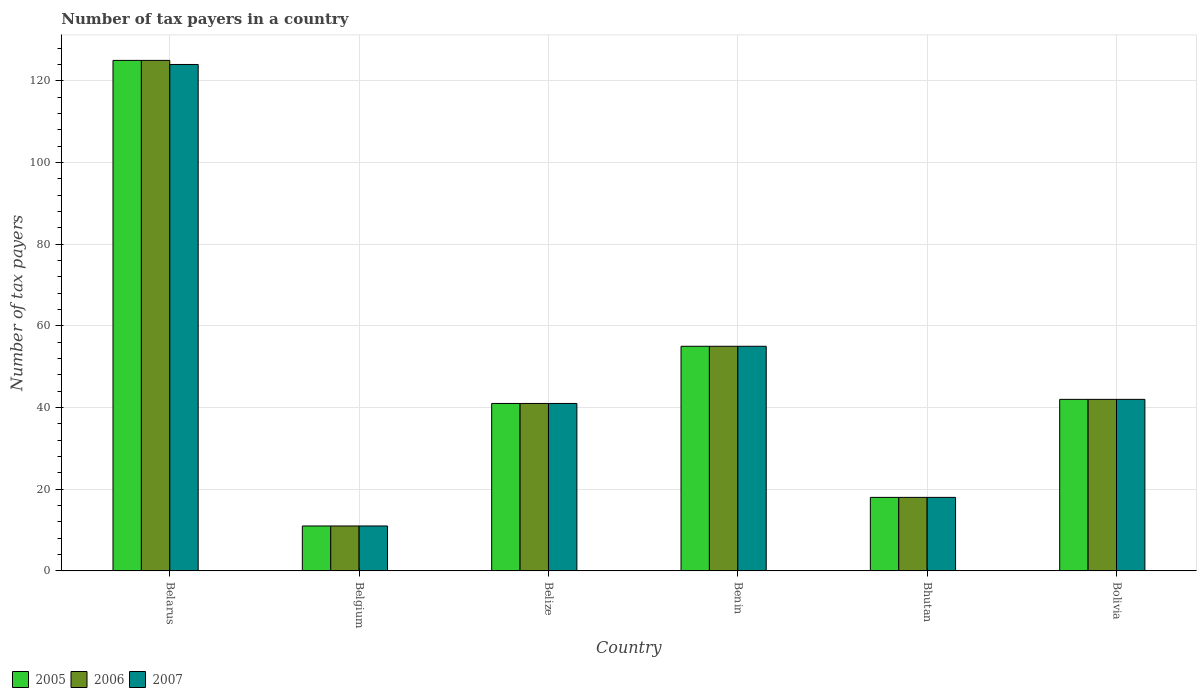How many different coloured bars are there?
Offer a terse response. 3. How many groups of bars are there?
Your answer should be very brief. 6. Are the number of bars on each tick of the X-axis equal?
Your answer should be compact. Yes. How many bars are there on the 2nd tick from the left?
Provide a short and direct response. 3. What is the label of the 5th group of bars from the left?
Your response must be concise. Bhutan. What is the number of tax payers in in 2007 in Bhutan?
Your response must be concise. 18. Across all countries, what is the maximum number of tax payers in in 2006?
Provide a short and direct response. 125. Across all countries, what is the minimum number of tax payers in in 2007?
Make the answer very short. 11. In which country was the number of tax payers in in 2007 maximum?
Provide a succinct answer. Belarus. What is the total number of tax payers in in 2007 in the graph?
Ensure brevity in your answer.  291. What is the difference between the number of tax payers in in 2006 in Benin and the number of tax payers in in 2007 in Belgium?
Make the answer very short. 44. What is the average number of tax payers in in 2005 per country?
Make the answer very short. 48.67. In how many countries, is the number of tax payers in in 2007 greater than 40?
Keep it short and to the point. 4. What is the ratio of the number of tax payers in in 2005 in Bhutan to that in Bolivia?
Ensure brevity in your answer.  0.43. Is the number of tax payers in in 2007 in Belgium less than that in Belize?
Provide a short and direct response. Yes. Is the difference between the number of tax payers in in 2006 in Belize and Bhutan greater than the difference between the number of tax payers in in 2005 in Belize and Bhutan?
Your response must be concise. No. What is the difference between the highest and the second highest number of tax payers in in 2005?
Provide a succinct answer. -83. What is the difference between the highest and the lowest number of tax payers in in 2005?
Make the answer very short. 114. In how many countries, is the number of tax payers in in 2007 greater than the average number of tax payers in in 2007 taken over all countries?
Give a very brief answer. 2. Is the sum of the number of tax payers in in 2006 in Belarus and Belize greater than the maximum number of tax payers in in 2007 across all countries?
Provide a short and direct response. Yes. What does the 2nd bar from the right in Belize represents?
Your answer should be very brief. 2006. Is it the case that in every country, the sum of the number of tax payers in in 2007 and number of tax payers in in 2006 is greater than the number of tax payers in in 2005?
Provide a short and direct response. Yes. How many countries are there in the graph?
Provide a short and direct response. 6. What is the difference between two consecutive major ticks on the Y-axis?
Your answer should be very brief. 20. Are the values on the major ticks of Y-axis written in scientific E-notation?
Keep it short and to the point. No. Does the graph contain any zero values?
Make the answer very short. No. Where does the legend appear in the graph?
Your response must be concise. Bottom left. How many legend labels are there?
Provide a short and direct response. 3. How are the legend labels stacked?
Give a very brief answer. Horizontal. What is the title of the graph?
Your answer should be compact. Number of tax payers in a country. Does "2003" appear as one of the legend labels in the graph?
Offer a terse response. No. What is the label or title of the X-axis?
Keep it short and to the point. Country. What is the label or title of the Y-axis?
Keep it short and to the point. Number of tax payers. What is the Number of tax payers in 2005 in Belarus?
Your answer should be very brief. 125. What is the Number of tax payers in 2006 in Belarus?
Give a very brief answer. 125. What is the Number of tax payers in 2007 in Belarus?
Your answer should be compact. 124. What is the Number of tax payers in 2006 in Belgium?
Give a very brief answer. 11. What is the Number of tax payers in 2005 in Benin?
Keep it short and to the point. 55. What is the Number of tax payers in 2006 in Benin?
Give a very brief answer. 55. What is the Number of tax payers of 2007 in Benin?
Keep it short and to the point. 55. What is the Number of tax payers of 2006 in Bolivia?
Make the answer very short. 42. Across all countries, what is the maximum Number of tax payers in 2005?
Give a very brief answer. 125. Across all countries, what is the maximum Number of tax payers of 2006?
Offer a very short reply. 125. Across all countries, what is the maximum Number of tax payers of 2007?
Give a very brief answer. 124. Across all countries, what is the minimum Number of tax payers in 2005?
Make the answer very short. 11. Across all countries, what is the minimum Number of tax payers of 2006?
Provide a short and direct response. 11. What is the total Number of tax payers in 2005 in the graph?
Offer a terse response. 292. What is the total Number of tax payers of 2006 in the graph?
Ensure brevity in your answer.  292. What is the total Number of tax payers in 2007 in the graph?
Give a very brief answer. 291. What is the difference between the Number of tax payers of 2005 in Belarus and that in Belgium?
Give a very brief answer. 114. What is the difference between the Number of tax payers of 2006 in Belarus and that in Belgium?
Ensure brevity in your answer.  114. What is the difference between the Number of tax payers in 2007 in Belarus and that in Belgium?
Your answer should be compact. 113. What is the difference between the Number of tax payers of 2005 in Belarus and that in Benin?
Give a very brief answer. 70. What is the difference between the Number of tax payers in 2006 in Belarus and that in Benin?
Ensure brevity in your answer.  70. What is the difference between the Number of tax payers of 2005 in Belarus and that in Bhutan?
Make the answer very short. 107. What is the difference between the Number of tax payers in 2006 in Belarus and that in Bhutan?
Ensure brevity in your answer.  107. What is the difference between the Number of tax payers in 2007 in Belarus and that in Bhutan?
Your answer should be very brief. 106. What is the difference between the Number of tax payers in 2006 in Belarus and that in Bolivia?
Ensure brevity in your answer.  83. What is the difference between the Number of tax payers of 2005 in Belgium and that in Belize?
Provide a succinct answer. -30. What is the difference between the Number of tax payers of 2006 in Belgium and that in Belize?
Ensure brevity in your answer.  -30. What is the difference between the Number of tax payers in 2005 in Belgium and that in Benin?
Offer a very short reply. -44. What is the difference between the Number of tax payers in 2006 in Belgium and that in Benin?
Provide a succinct answer. -44. What is the difference between the Number of tax payers of 2007 in Belgium and that in Benin?
Your response must be concise. -44. What is the difference between the Number of tax payers of 2005 in Belgium and that in Bhutan?
Give a very brief answer. -7. What is the difference between the Number of tax payers in 2006 in Belgium and that in Bhutan?
Offer a very short reply. -7. What is the difference between the Number of tax payers of 2007 in Belgium and that in Bhutan?
Offer a very short reply. -7. What is the difference between the Number of tax payers in 2005 in Belgium and that in Bolivia?
Give a very brief answer. -31. What is the difference between the Number of tax payers in 2006 in Belgium and that in Bolivia?
Provide a short and direct response. -31. What is the difference between the Number of tax payers of 2007 in Belgium and that in Bolivia?
Give a very brief answer. -31. What is the difference between the Number of tax payers in 2006 in Belize and that in Benin?
Make the answer very short. -14. What is the difference between the Number of tax payers in 2007 in Belize and that in Benin?
Provide a short and direct response. -14. What is the difference between the Number of tax payers in 2005 in Belize and that in Bhutan?
Make the answer very short. 23. What is the difference between the Number of tax payers in 2006 in Belize and that in Bhutan?
Provide a succinct answer. 23. What is the difference between the Number of tax payers in 2007 in Belize and that in Bolivia?
Offer a very short reply. -1. What is the difference between the Number of tax payers of 2005 in Benin and that in Bhutan?
Provide a short and direct response. 37. What is the difference between the Number of tax payers in 2006 in Benin and that in Bhutan?
Your answer should be very brief. 37. What is the difference between the Number of tax payers in 2007 in Benin and that in Bhutan?
Ensure brevity in your answer.  37. What is the difference between the Number of tax payers in 2005 in Benin and that in Bolivia?
Give a very brief answer. 13. What is the difference between the Number of tax payers in 2007 in Benin and that in Bolivia?
Your answer should be compact. 13. What is the difference between the Number of tax payers in 2005 in Bhutan and that in Bolivia?
Make the answer very short. -24. What is the difference between the Number of tax payers of 2005 in Belarus and the Number of tax payers of 2006 in Belgium?
Offer a terse response. 114. What is the difference between the Number of tax payers in 2005 in Belarus and the Number of tax payers in 2007 in Belgium?
Make the answer very short. 114. What is the difference between the Number of tax payers of 2006 in Belarus and the Number of tax payers of 2007 in Belgium?
Your response must be concise. 114. What is the difference between the Number of tax payers in 2005 in Belarus and the Number of tax payers in 2006 in Benin?
Your response must be concise. 70. What is the difference between the Number of tax payers in 2006 in Belarus and the Number of tax payers in 2007 in Benin?
Give a very brief answer. 70. What is the difference between the Number of tax payers in 2005 in Belarus and the Number of tax payers in 2006 in Bhutan?
Ensure brevity in your answer.  107. What is the difference between the Number of tax payers in 2005 in Belarus and the Number of tax payers in 2007 in Bhutan?
Ensure brevity in your answer.  107. What is the difference between the Number of tax payers of 2006 in Belarus and the Number of tax payers of 2007 in Bhutan?
Your response must be concise. 107. What is the difference between the Number of tax payers in 2005 in Belgium and the Number of tax payers in 2006 in Belize?
Make the answer very short. -30. What is the difference between the Number of tax payers in 2005 in Belgium and the Number of tax payers in 2007 in Belize?
Make the answer very short. -30. What is the difference between the Number of tax payers in 2005 in Belgium and the Number of tax payers in 2006 in Benin?
Your answer should be very brief. -44. What is the difference between the Number of tax payers of 2005 in Belgium and the Number of tax payers of 2007 in Benin?
Your response must be concise. -44. What is the difference between the Number of tax payers in 2006 in Belgium and the Number of tax payers in 2007 in Benin?
Keep it short and to the point. -44. What is the difference between the Number of tax payers in 2005 in Belgium and the Number of tax payers in 2006 in Bhutan?
Provide a short and direct response. -7. What is the difference between the Number of tax payers of 2006 in Belgium and the Number of tax payers of 2007 in Bhutan?
Ensure brevity in your answer.  -7. What is the difference between the Number of tax payers of 2005 in Belgium and the Number of tax payers of 2006 in Bolivia?
Ensure brevity in your answer.  -31. What is the difference between the Number of tax payers in 2005 in Belgium and the Number of tax payers in 2007 in Bolivia?
Keep it short and to the point. -31. What is the difference between the Number of tax payers in 2006 in Belgium and the Number of tax payers in 2007 in Bolivia?
Your response must be concise. -31. What is the difference between the Number of tax payers in 2005 in Belize and the Number of tax payers in 2006 in Bhutan?
Give a very brief answer. 23. What is the difference between the Number of tax payers of 2005 in Belize and the Number of tax payers of 2007 in Bhutan?
Offer a very short reply. 23. What is the difference between the Number of tax payers of 2005 in Belize and the Number of tax payers of 2006 in Bolivia?
Offer a terse response. -1. What is the difference between the Number of tax payers in 2006 in Belize and the Number of tax payers in 2007 in Bolivia?
Provide a succinct answer. -1. What is the difference between the Number of tax payers of 2005 in Benin and the Number of tax payers of 2006 in Bolivia?
Keep it short and to the point. 13. What is the average Number of tax payers of 2005 per country?
Provide a succinct answer. 48.67. What is the average Number of tax payers in 2006 per country?
Provide a short and direct response. 48.67. What is the average Number of tax payers of 2007 per country?
Your response must be concise. 48.5. What is the difference between the Number of tax payers in 2005 and Number of tax payers in 2007 in Belarus?
Your response must be concise. 1. What is the difference between the Number of tax payers in 2006 and Number of tax payers in 2007 in Belarus?
Keep it short and to the point. 1. What is the difference between the Number of tax payers in 2005 and Number of tax payers in 2006 in Belgium?
Give a very brief answer. 0. What is the difference between the Number of tax payers in 2005 and Number of tax payers in 2007 in Belgium?
Give a very brief answer. 0. What is the difference between the Number of tax payers in 2005 and Number of tax payers in 2006 in Belize?
Give a very brief answer. 0. What is the difference between the Number of tax payers of 2005 and Number of tax payers of 2007 in Belize?
Ensure brevity in your answer.  0. What is the difference between the Number of tax payers of 2006 and Number of tax payers of 2007 in Belize?
Ensure brevity in your answer.  0. What is the difference between the Number of tax payers in 2005 and Number of tax payers in 2007 in Benin?
Offer a very short reply. 0. What is the difference between the Number of tax payers in 2005 and Number of tax payers in 2007 in Bhutan?
Keep it short and to the point. 0. What is the difference between the Number of tax payers in 2006 and Number of tax payers in 2007 in Bolivia?
Give a very brief answer. 0. What is the ratio of the Number of tax payers in 2005 in Belarus to that in Belgium?
Provide a succinct answer. 11.36. What is the ratio of the Number of tax payers of 2006 in Belarus to that in Belgium?
Your response must be concise. 11.36. What is the ratio of the Number of tax payers in 2007 in Belarus to that in Belgium?
Your answer should be compact. 11.27. What is the ratio of the Number of tax payers in 2005 in Belarus to that in Belize?
Your response must be concise. 3.05. What is the ratio of the Number of tax payers of 2006 in Belarus to that in Belize?
Offer a very short reply. 3.05. What is the ratio of the Number of tax payers of 2007 in Belarus to that in Belize?
Offer a terse response. 3.02. What is the ratio of the Number of tax payers of 2005 in Belarus to that in Benin?
Your response must be concise. 2.27. What is the ratio of the Number of tax payers in 2006 in Belarus to that in Benin?
Provide a short and direct response. 2.27. What is the ratio of the Number of tax payers of 2007 in Belarus to that in Benin?
Offer a terse response. 2.25. What is the ratio of the Number of tax payers of 2005 in Belarus to that in Bhutan?
Provide a short and direct response. 6.94. What is the ratio of the Number of tax payers in 2006 in Belarus to that in Bhutan?
Make the answer very short. 6.94. What is the ratio of the Number of tax payers of 2007 in Belarus to that in Bhutan?
Provide a succinct answer. 6.89. What is the ratio of the Number of tax payers in 2005 in Belarus to that in Bolivia?
Your answer should be very brief. 2.98. What is the ratio of the Number of tax payers of 2006 in Belarus to that in Bolivia?
Your answer should be compact. 2.98. What is the ratio of the Number of tax payers of 2007 in Belarus to that in Bolivia?
Ensure brevity in your answer.  2.95. What is the ratio of the Number of tax payers in 2005 in Belgium to that in Belize?
Make the answer very short. 0.27. What is the ratio of the Number of tax payers of 2006 in Belgium to that in Belize?
Your answer should be compact. 0.27. What is the ratio of the Number of tax payers of 2007 in Belgium to that in Belize?
Provide a succinct answer. 0.27. What is the ratio of the Number of tax payers of 2005 in Belgium to that in Benin?
Your answer should be compact. 0.2. What is the ratio of the Number of tax payers of 2005 in Belgium to that in Bhutan?
Ensure brevity in your answer.  0.61. What is the ratio of the Number of tax payers of 2006 in Belgium to that in Bhutan?
Your answer should be very brief. 0.61. What is the ratio of the Number of tax payers of 2007 in Belgium to that in Bhutan?
Make the answer very short. 0.61. What is the ratio of the Number of tax payers in 2005 in Belgium to that in Bolivia?
Your answer should be compact. 0.26. What is the ratio of the Number of tax payers of 2006 in Belgium to that in Bolivia?
Offer a terse response. 0.26. What is the ratio of the Number of tax payers in 2007 in Belgium to that in Bolivia?
Offer a very short reply. 0.26. What is the ratio of the Number of tax payers in 2005 in Belize to that in Benin?
Provide a short and direct response. 0.75. What is the ratio of the Number of tax payers of 2006 in Belize to that in Benin?
Provide a succinct answer. 0.75. What is the ratio of the Number of tax payers in 2007 in Belize to that in Benin?
Offer a terse response. 0.75. What is the ratio of the Number of tax payers in 2005 in Belize to that in Bhutan?
Offer a terse response. 2.28. What is the ratio of the Number of tax payers in 2006 in Belize to that in Bhutan?
Your answer should be compact. 2.28. What is the ratio of the Number of tax payers of 2007 in Belize to that in Bhutan?
Your answer should be compact. 2.28. What is the ratio of the Number of tax payers of 2005 in Belize to that in Bolivia?
Give a very brief answer. 0.98. What is the ratio of the Number of tax payers in 2006 in Belize to that in Bolivia?
Make the answer very short. 0.98. What is the ratio of the Number of tax payers of 2007 in Belize to that in Bolivia?
Your answer should be very brief. 0.98. What is the ratio of the Number of tax payers in 2005 in Benin to that in Bhutan?
Provide a short and direct response. 3.06. What is the ratio of the Number of tax payers in 2006 in Benin to that in Bhutan?
Your answer should be compact. 3.06. What is the ratio of the Number of tax payers in 2007 in Benin to that in Bhutan?
Offer a very short reply. 3.06. What is the ratio of the Number of tax payers of 2005 in Benin to that in Bolivia?
Make the answer very short. 1.31. What is the ratio of the Number of tax payers in 2006 in Benin to that in Bolivia?
Your answer should be compact. 1.31. What is the ratio of the Number of tax payers of 2007 in Benin to that in Bolivia?
Provide a succinct answer. 1.31. What is the ratio of the Number of tax payers in 2005 in Bhutan to that in Bolivia?
Offer a terse response. 0.43. What is the ratio of the Number of tax payers of 2006 in Bhutan to that in Bolivia?
Your answer should be very brief. 0.43. What is the ratio of the Number of tax payers in 2007 in Bhutan to that in Bolivia?
Your answer should be very brief. 0.43. What is the difference between the highest and the second highest Number of tax payers of 2005?
Give a very brief answer. 70. What is the difference between the highest and the second highest Number of tax payers in 2007?
Ensure brevity in your answer.  69. What is the difference between the highest and the lowest Number of tax payers of 2005?
Make the answer very short. 114. What is the difference between the highest and the lowest Number of tax payers of 2006?
Make the answer very short. 114. What is the difference between the highest and the lowest Number of tax payers in 2007?
Your answer should be compact. 113. 